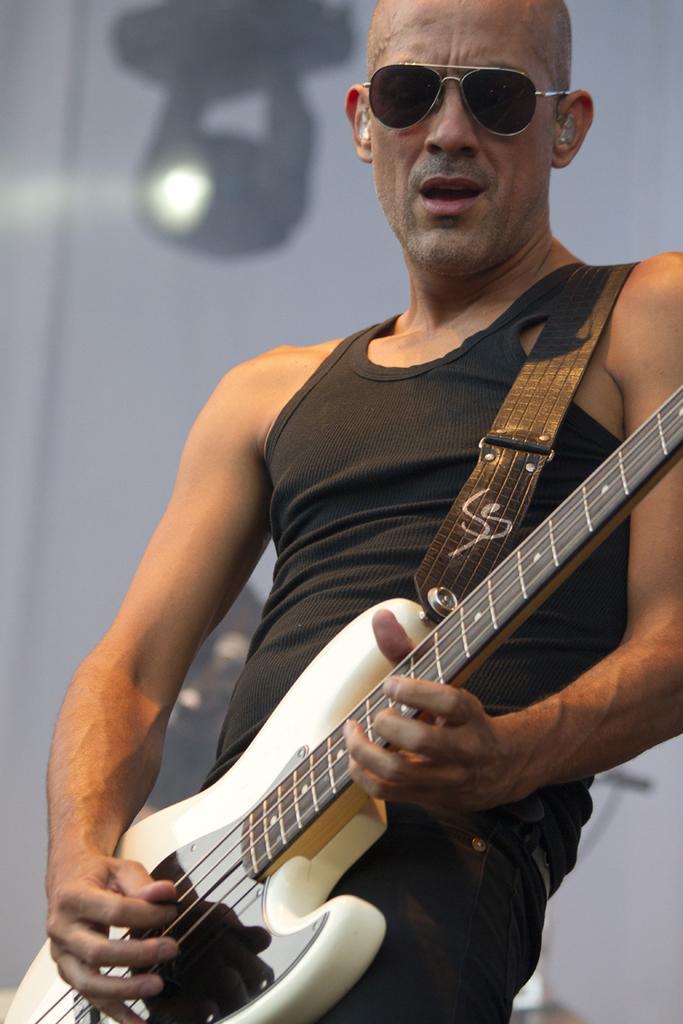Describe this image in one or two sentences. In this image I can see a man playing a guitar. In the background I can see a light. This man is wearing black color vest and black color goggles. 